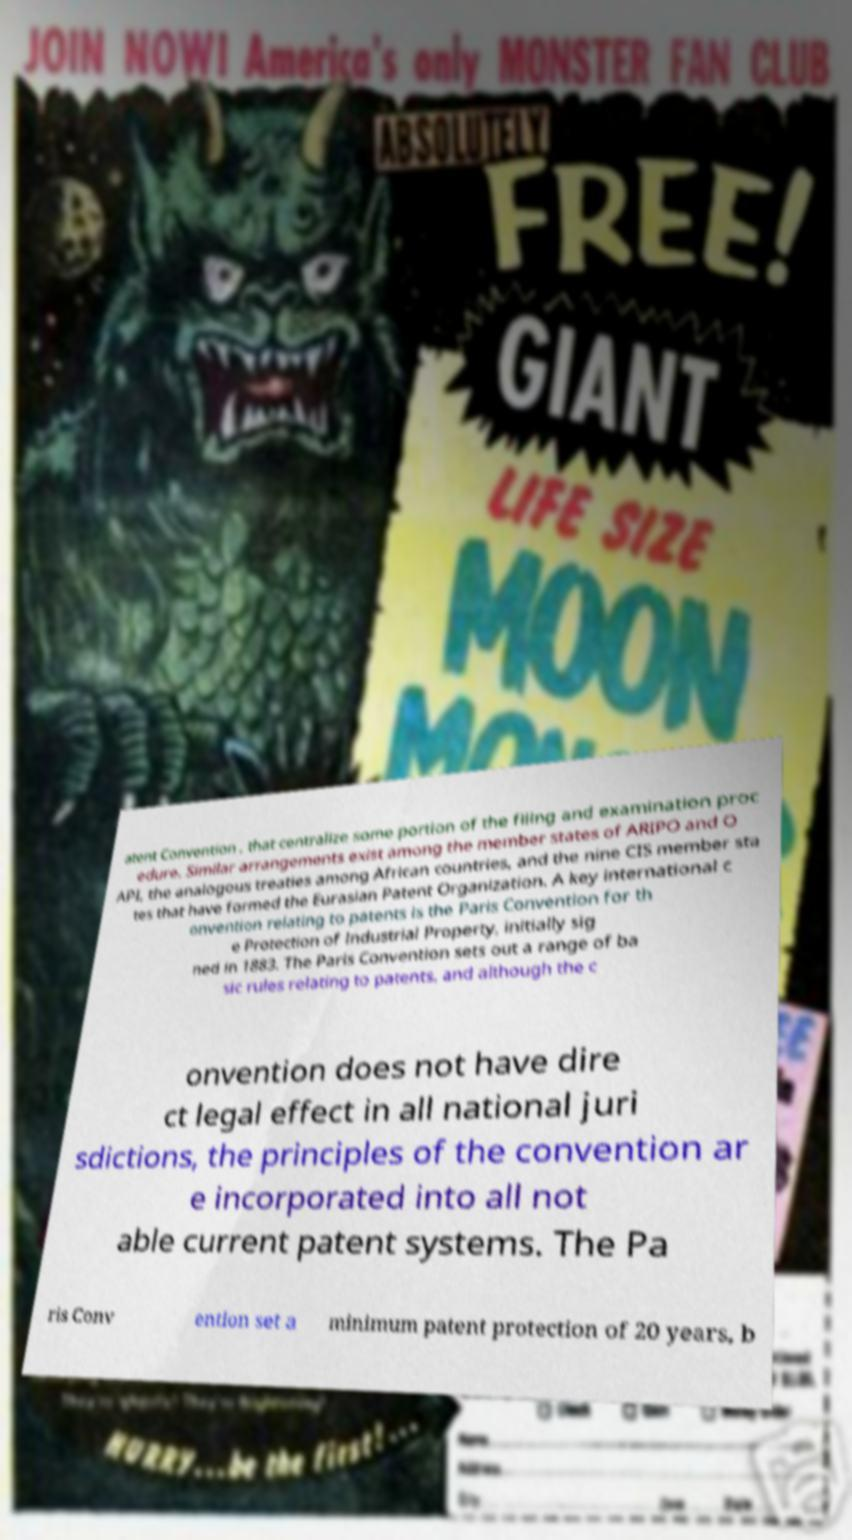Could you assist in decoding the text presented in this image and type it out clearly? atent Convention , that centralize some portion of the filing and examination proc edure. Similar arrangements exist among the member states of ARIPO and O API, the analogous treaties among African countries, and the nine CIS member sta tes that have formed the Eurasian Patent Organization. A key international c onvention relating to patents is the Paris Convention for th e Protection of Industrial Property, initially sig ned in 1883. The Paris Convention sets out a range of ba sic rules relating to patents, and although the c onvention does not have dire ct legal effect in all national juri sdictions, the principles of the convention ar e incorporated into all not able current patent systems. The Pa ris Conv ention set a minimum patent protection of 20 years, b 